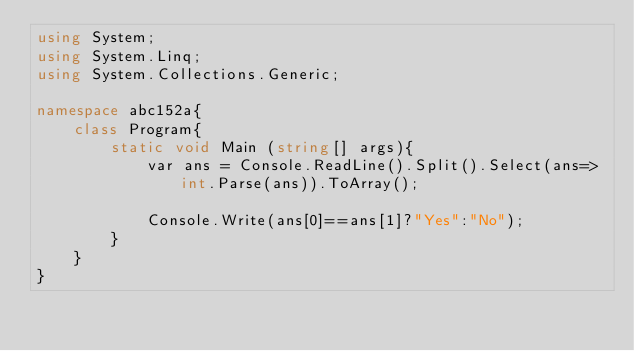<code> <loc_0><loc_0><loc_500><loc_500><_C#_>using System;
using System.Linq;
using System.Collections.Generic;

namespace abc152a{
    class Program{
        static void Main (string[] args){
            var ans = Console.ReadLine().Split().Select(ans=>int.Parse(ans)).ToArray();
            
            Console.Write(ans[0]==ans[1]?"Yes":"No");
        }
    }
}</code> 